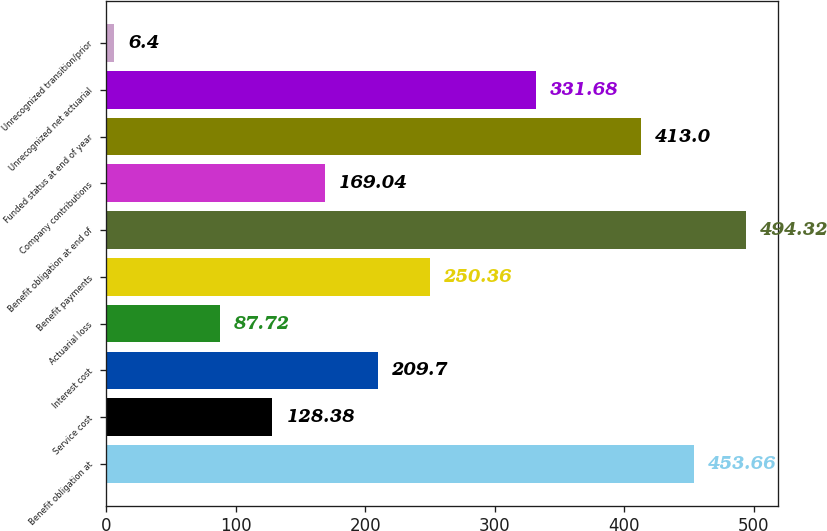<chart> <loc_0><loc_0><loc_500><loc_500><bar_chart><fcel>Benefit obligation at<fcel>Service cost<fcel>Interest cost<fcel>Actuarial loss<fcel>Benefit payments<fcel>Benefit obligation at end of<fcel>Company contributions<fcel>Funded status at end of year<fcel>Unrecognized net actuarial<fcel>Unrecognized transition/prior<nl><fcel>453.66<fcel>128.38<fcel>209.7<fcel>87.72<fcel>250.36<fcel>494.32<fcel>169.04<fcel>413<fcel>331.68<fcel>6.4<nl></chart> 